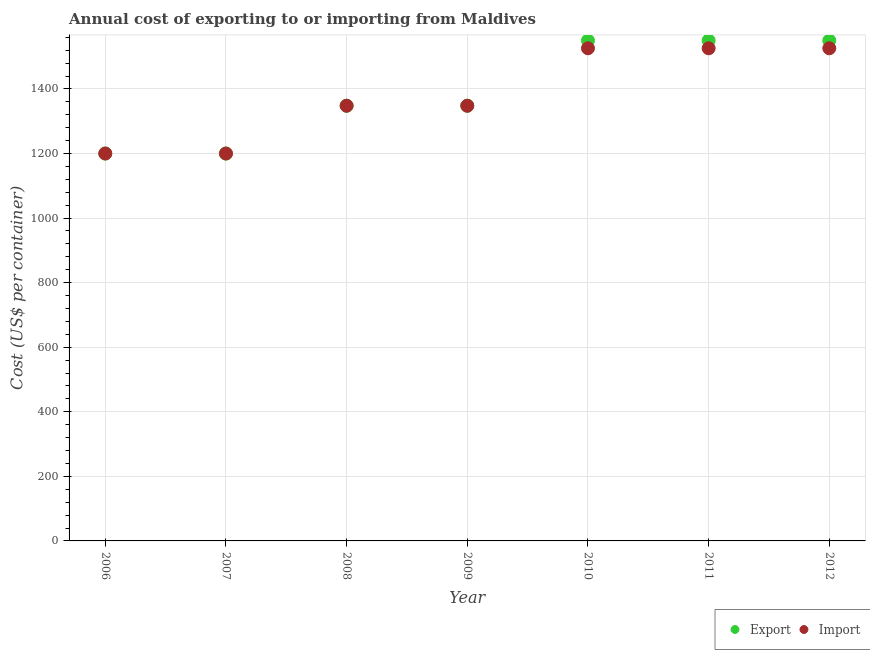Is the number of dotlines equal to the number of legend labels?
Your answer should be compact. Yes. What is the import cost in 2007?
Provide a succinct answer. 1200. Across all years, what is the maximum export cost?
Keep it short and to the point. 1550. Across all years, what is the minimum import cost?
Give a very brief answer. 1200. In which year was the import cost maximum?
Your answer should be compact. 2010. What is the total import cost in the graph?
Offer a very short reply. 9674. What is the difference between the export cost in 2007 and that in 2008?
Offer a very short reply. -148. What is the difference between the export cost in 2007 and the import cost in 2009?
Make the answer very short. -148. What is the average import cost per year?
Provide a short and direct response. 1382. In the year 2011, what is the difference between the import cost and export cost?
Give a very brief answer. -24. What is the ratio of the import cost in 2009 to that in 2012?
Your answer should be very brief. 0.88. Is the export cost in 2008 less than that in 2010?
Provide a short and direct response. Yes. What is the difference between the highest and the lowest import cost?
Keep it short and to the point. 326. Does the export cost monotonically increase over the years?
Your answer should be very brief. No. What is the difference between two consecutive major ticks on the Y-axis?
Keep it short and to the point. 200. Are the values on the major ticks of Y-axis written in scientific E-notation?
Give a very brief answer. No. Where does the legend appear in the graph?
Provide a short and direct response. Bottom right. How many legend labels are there?
Ensure brevity in your answer.  2. What is the title of the graph?
Make the answer very short. Annual cost of exporting to or importing from Maldives. Does "Death rate" appear as one of the legend labels in the graph?
Your answer should be compact. No. What is the label or title of the Y-axis?
Your answer should be very brief. Cost (US$ per container). What is the Cost (US$ per container) of Export in 2006?
Offer a terse response. 1200. What is the Cost (US$ per container) in Import in 2006?
Your response must be concise. 1200. What is the Cost (US$ per container) in Export in 2007?
Offer a very short reply. 1200. What is the Cost (US$ per container) in Import in 2007?
Ensure brevity in your answer.  1200. What is the Cost (US$ per container) of Export in 2008?
Make the answer very short. 1348. What is the Cost (US$ per container) in Import in 2008?
Offer a terse response. 1348. What is the Cost (US$ per container) in Export in 2009?
Make the answer very short. 1348. What is the Cost (US$ per container) of Import in 2009?
Your answer should be compact. 1348. What is the Cost (US$ per container) in Export in 2010?
Your response must be concise. 1550. What is the Cost (US$ per container) in Import in 2010?
Keep it short and to the point. 1526. What is the Cost (US$ per container) of Export in 2011?
Offer a very short reply. 1550. What is the Cost (US$ per container) in Import in 2011?
Keep it short and to the point. 1526. What is the Cost (US$ per container) in Export in 2012?
Ensure brevity in your answer.  1550. What is the Cost (US$ per container) of Import in 2012?
Your answer should be very brief. 1526. Across all years, what is the maximum Cost (US$ per container) of Export?
Provide a short and direct response. 1550. Across all years, what is the maximum Cost (US$ per container) of Import?
Make the answer very short. 1526. Across all years, what is the minimum Cost (US$ per container) in Export?
Make the answer very short. 1200. Across all years, what is the minimum Cost (US$ per container) in Import?
Offer a very short reply. 1200. What is the total Cost (US$ per container) of Export in the graph?
Make the answer very short. 9746. What is the total Cost (US$ per container) of Import in the graph?
Keep it short and to the point. 9674. What is the difference between the Cost (US$ per container) of Export in 2006 and that in 2008?
Offer a very short reply. -148. What is the difference between the Cost (US$ per container) of Import in 2006 and that in 2008?
Offer a very short reply. -148. What is the difference between the Cost (US$ per container) in Export in 2006 and that in 2009?
Give a very brief answer. -148. What is the difference between the Cost (US$ per container) of Import in 2006 and that in 2009?
Give a very brief answer. -148. What is the difference between the Cost (US$ per container) of Export in 2006 and that in 2010?
Offer a very short reply. -350. What is the difference between the Cost (US$ per container) in Import in 2006 and that in 2010?
Provide a short and direct response. -326. What is the difference between the Cost (US$ per container) of Export in 2006 and that in 2011?
Provide a succinct answer. -350. What is the difference between the Cost (US$ per container) in Import in 2006 and that in 2011?
Offer a terse response. -326. What is the difference between the Cost (US$ per container) in Export in 2006 and that in 2012?
Your answer should be very brief. -350. What is the difference between the Cost (US$ per container) in Import in 2006 and that in 2012?
Your answer should be very brief. -326. What is the difference between the Cost (US$ per container) in Export in 2007 and that in 2008?
Provide a short and direct response. -148. What is the difference between the Cost (US$ per container) in Import in 2007 and that in 2008?
Provide a succinct answer. -148. What is the difference between the Cost (US$ per container) of Export in 2007 and that in 2009?
Offer a terse response. -148. What is the difference between the Cost (US$ per container) of Import in 2007 and that in 2009?
Give a very brief answer. -148. What is the difference between the Cost (US$ per container) in Export in 2007 and that in 2010?
Offer a terse response. -350. What is the difference between the Cost (US$ per container) in Import in 2007 and that in 2010?
Keep it short and to the point. -326. What is the difference between the Cost (US$ per container) in Export in 2007 and that in 2011?
Ensure brevity in your answer.  -350. What is the difference between the Cost (US$ per container) of Import in 2007 and that in 2011?
Your answer should be compact. -326. What is the difference between the Cost (US$ per container) of Export in 2007 and that in 2012?
Keep it short and to the point. -350. What is the difference between the Cost (US$ per container) in Import in 2007 and that in 2012?
Provide a short and direct response. -326. What is the difference between the Cost (US$ per container) of Export in 2008 and that in 2009?
Offer a very short reply. 0. What is the difference between the Cost (US$ per container) in Export in 2008 and that in 2010?
Ensure brevity in your answer.  -202. What is the difference between the Cost (US$ per container) of Import in 2008 and that in 2010?
Your response must be concise. -178. What is the difference between the Cost (US$ per container) in Export in 2008 and that in 2011?
Ensure brevity in your answer.  -202. What is the difference between the Cost (US$ per container) in Import in 2008 and that in 2011?
Ensure brevity in your answer.  -178. What is the difference between the Cost (US$ per container) in Export in 2008 and that in 2012?
Offer a terse response. -202. What is the difference between the Cost (US$ per container) of Import in 2008 and that in 2012?
Offer a very short reply. -178. What is the difference between the Cost (US$ per container) of Export in 2009 and that in 2010?
Provide a short and direct response. -202. What is the difference between the Cost (US$ per container) in Import in 2009 and that in 2010?
Keep it short and to the point. -178. What is the difference between the Cost (US$ per container) in Export in 2009 and that in 2011?
Make the answer very short. -202. What is the difference between the Cost (US$ per container) of Import in 2009 and that in 2011?
Offer a terse response. -178. What is the difference between the Cost (US$ per container) in Export in 2009 and that in 2012?
Your response must be concise. -202. What is the difference between the Cost (US$ per container) of Import in 2009 and that in 2012?
Offer a terse response. -178. What is the difference between the Cost (US$ per container) in Export in 2010 and that in 2011?
Provide a short and direct response. 0. What is the difference between the Cost (US$ per container) of Import in 2010 and that in 2011?
Give a very brief answer. 0. What is the difference between the Cost (US$ per container) of Import in 2010 and that in 2012?
Your answer should be compact. 0. What is the difference between the Cost (US$ per container) in Import in 2011 and that in 2012?
Your answer should be compact. 0. What is the difference between the Cost (US$ per container) of Export in 2006 and the Cost (US$ per container) of Import in 2008?
Provide a succinct answer. -148. What is the difference between the Cost (US$ per container) of Export in 2006 and the Cost (US$ per container) of Import in 2009?
Provide a short and direct response. -148. What is the difference between the Cost (US$ per container) in Export in 2006 and the Cost (US$ per container) in Import in 2010?
Your response must be concise. -326. What is the difference between the Cost (US$ per container) of Export in 2006 and the Cost (US$ per container) of Import in 2011?
Make the answer very short. -326. What is the difference between the Cost (US$ per container) of Export in 2006 and the Cost (US$ per container) of Import in 2012?
Offer a very short reply. -326. What is the difference between the Cost (US$ per container) of Export in 2007 and the Cost (US$ per container) of Import in 2008?
Ensure brevity in your answer.  -148. What is the difference between the Cost (US$ per container) in Export in 2007 and the Cost (US$ per container) in Import in 2009?
Your answer should be very brief. -148. What is the difference between the Cost (US$ per container) of Export in 2007 and the Cost (US$ per container) of Import in 2010?
Give a very brief answer. -326. What is the difference between the Cost (US$ per container) of Export in 2007 and the Cost (US$ per container) of Import in 2011?
Give a very brief answer. -326. What is the difference between the Cost (US$ per container) of Export in 2007 and the Cost (US$ per container) of Import in 2012?
Keep it short and to the point. -326. What is the difference between the Cost (US$ per container) in Export in 2008 and the Cost (US$ per container) in Import in 2010?
Offer a very short reply. -178. What is the difference between the Cost (US$ per container) in Export in 2008 and the Cost (US$ per container) in Import in 2011?
Your response must be concise. -178. What is the difference between the Cost (US$ per container) in Export in 2008 and the Cost (US$ per container) in Import in 2012?
Provide a succinct answer. -178. What is the difference between the Cost (US$ per container) of Export in 2009 and the Cost (US$ per container) of Import in 2010?
Offer a terse response. -178. What is the difference between the Cost (US$ per container) of Export in 2009 and the Cost (US$ per container) of Import in 2011?
Make the answer very short. -178. What is the difference between the Cost (US$ per container) of Export in 2009 and the Cost (US$ per container) of Import in 2012?
Your response must be concise. -178. What is the difference between the Cost (US$ per container) of Export in 2010 and the Cost (US$ per container) of Import in 2011?
Keep it short and to the point. 24. What is the difference between the Cost (US$ per container) of Export in 2010 and the Cost (US$ per container) of Import in 2012?
Offer a terse response. 24. What is the difference between the Cost (US$ per container) in Export in 2011 and the Cost (US$ per container) in Import in 2012?
Ensure brevity in your answer.  24. What is the average Cost (US$ per container) of Export per year?
Make the answer very short. 1392.29. What is the average Cost (US$ per container) in Import per year?
Give a very brief answer. 1382. In the year 2007, what is the difference between the Cost (US$ per container) of Export and Cost (US$ per container) of Import?
Your answer should be compact. 0. In the year 2009, what is the difference between the Cost (US$ per container) of Export and Cost (US$ per container) of Import?
Ensure brevity in your answer.  0. In the year 2010, what is the difference between the Cost (US$ per container) of Export and Cost (US$ per container) of Import?
Offer a very short reply. 24. In the year 2012, what is the difference between the Cost (US$ per container) in Export and Cost (US$ per container) in Import?
Provide a succinct answer. 24. What is the ratio of the Cost (US$ per container) in Export in 2006 to that in 2007?
Your response must be concise. 1. What is the ratio of the Cost (US$ per container) of Export in 2006 to that in 2008?
Your answer should be compact. 0.89. What is the ratio of the Cost (US$ per container) of Import in 2006 to that in 2008?
Offer a terse response. 0.89. What is the ratio of the Cost (US$ per container) of Export in 2006 to that in 2009?
Give a very brief answer. 0.89. What is the ratio of the Cost (US$ per container) in Import in 2006 to that in 2009?
Ensure brevity in your answer.  0.89. What is the ratio of the Cost (US$ per container) in Export in 2006 to that in 2010?
Keep it short and to the point. 0.77. What is the ratio of the Cost (US$ per container) of Import in 2006 to that in 2010?
Provide a succinct answer. 0.79. What is the ratio of the Cost (US$ per container) in Export in 2006 to that in 2011?
Give a very brief answer. 0.77. What is the ratio of the Cost (US$ per container) in Import in 2006 to that in 2011?
Offer a very short reply. 0.79. What is the ratio of the Cost (US$ per container) in Export in 2006 to that in 2012?
Make the answer very short. 0.77. What is the ratio of the Cost (US$ per container) in Import in 2006 to that in 2012?
Provide a short and direct response. 0.79. What is the ratio of the Cost (US$ per container) in Export in 2007 to that in 2008?
Offer a very short reply. 0.89. What is the ratio of the Cost (US$ per container) in Import in 2007 to that in 2008?
Make the answer very short. 0.89. What is the ratio of the Cost (US$ per container) in Export in 2007 to that in 2009?
Your answer should be compact. 0.89. What is the ratio of the Cost (US$ per container) in Import in 2007 to that in 2009?
Ensure brevity in your answer.  0.89. What is the ratio of the Cost (US$ per container) of Export in 2007 to that in 2010?
Give a very brief answer. 0.77. What is the ratio of the Cost (US$ per container) of Import in 2007 to that in 2010?
Ensure brevity in your answer.  0.79. What is the ratio of the Cost (US$ per container) in Export in 2007 to that in 2011?
Your response must be concise. 0.77. What is the ratio of the Cost (US$ per container) of Import in 2007 to that in 2011?
Make the answer very short. 0.79. What is the ratio of the Cost (US$ per container) in Export in 2007 to that in 2012?
Make the answer very short. 0.77. What is the ratio of the Cost (US$ per container) of Import in 2007 to that in 2012?
Give a very brief answer. 0.79. What is the ratio of the Cost (US$ per container) in Export in 2008 to that in 2009?
Give a very brief answer. 1. What is the ratio of the Cost (US$ per container) of Export in 2008 to that in 2010?
Give a very brief answer. 0.87. What is the ratio of the Cost (US$ per container) in Import in 2008 to that in 2010?
Keep it short and to the point. 0.88. What is the ratio of the Cost (US$ per container) of Export in 2008 to that in 2011?
Ensure brevity in your answer.  0.87. What is the ratio of the Cost (US$ per container) of Import in 2008 to that in 2011?
Give a very brief answer. 0.88. What is the ratio of the Cost (US$ per container) of Export in 2008 to that in 2012?
Offer a terse response. 0.87. What is the ratio of the Cost (US$ per container) in Import in 2008 to that in 2012?
Provide a succinct answer. 0.88. What is the ratio of the Cost (US$ per container) of Export in 2009 to that in 2010?
Your answer should be compact. 0.87. What is the ratio of the Cost (US$ per container) of Import in 2009 to that in 2010?
Provide a succinct answer. 0.88. What is the ratio of the Cost (US$ per container) in Export in 2009 to that in 2011?
Your answer should be compact. 0.87. What is the ratio of the Cost (US$ per container) in Import in 2009 to that in 2011?
Provide a succinct answer. 0.88. What is the ratio of the Cost (US$ per container) of Export in 2009 to that in 2012?
Ensure brevity in your answer.  0.87. What is the ratio of the Cost (US$ per container) in Import in 2009 to that in 2012?
Provide a succinct answer. 0.88. What is the ratio of the Cost (US$ per container) in Import in 2010 to that in 2011?
Ensure brevity in your answer.  1. What is the ratio of the Cost (US$ per container) of Export in 2010 to that in 2012?
Offer a terse response. 1. What is the ratio of the Cost (US$ per container) in Import in 2010 to that in 2012?
Your response must be concise. 1. What is the ratio of the Cost (US$ per container) of Export in 2011 to that in 2012?
Offer a very short reply. 1. What is the difference between the highest and the second highest Cost (US$ per container) in Export?
Offer a terse response. 0. What is the difference between the highest and the second highest Cost (US$ per container) in Import?
Your response must be concise. 0. What is the difference between the highest and the lowest Cost (US$ per container) in Export?
Provide a short and direct response. 350. What is the difference between the highest and the lowest Cost (US$ per container) in Import?
Provide a succinct answer. 326. 